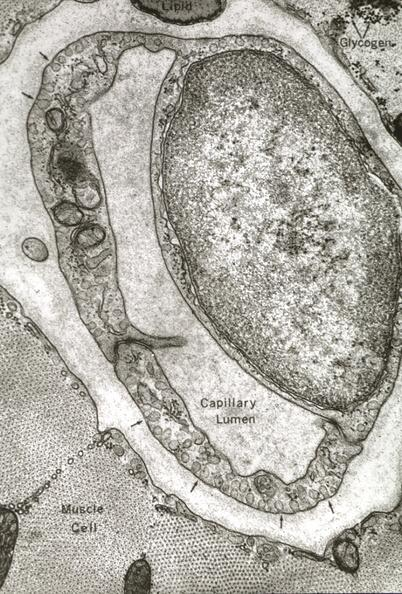what does this image show?
Answer the question using a single word or phrase. Skeletal muscle 